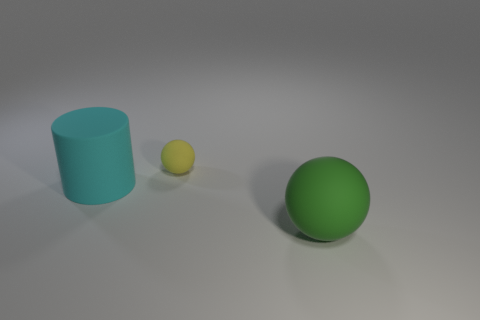Add 3 rubber balls. How many objects exist? 6 Subtract 2 spheres. How many spheres are left? 0 Subtract all cyan matte objects. Subtract all small objects. How many objects are left? 1 Add 2 cyan matte objects. How many cyan matte objects are left? 3 Add 3 cyan matte objects. How many cyan matte objects exist? 4 Subtract 0 gray spheres. How many objects are left? 3 Subtract all balls. How many objects are left? 1 Subtract all blue cylinders. Subtract all brown spheres. How many cylinders are left? 1 Subtract all gray blocks. How many yellow balls are left? 1 